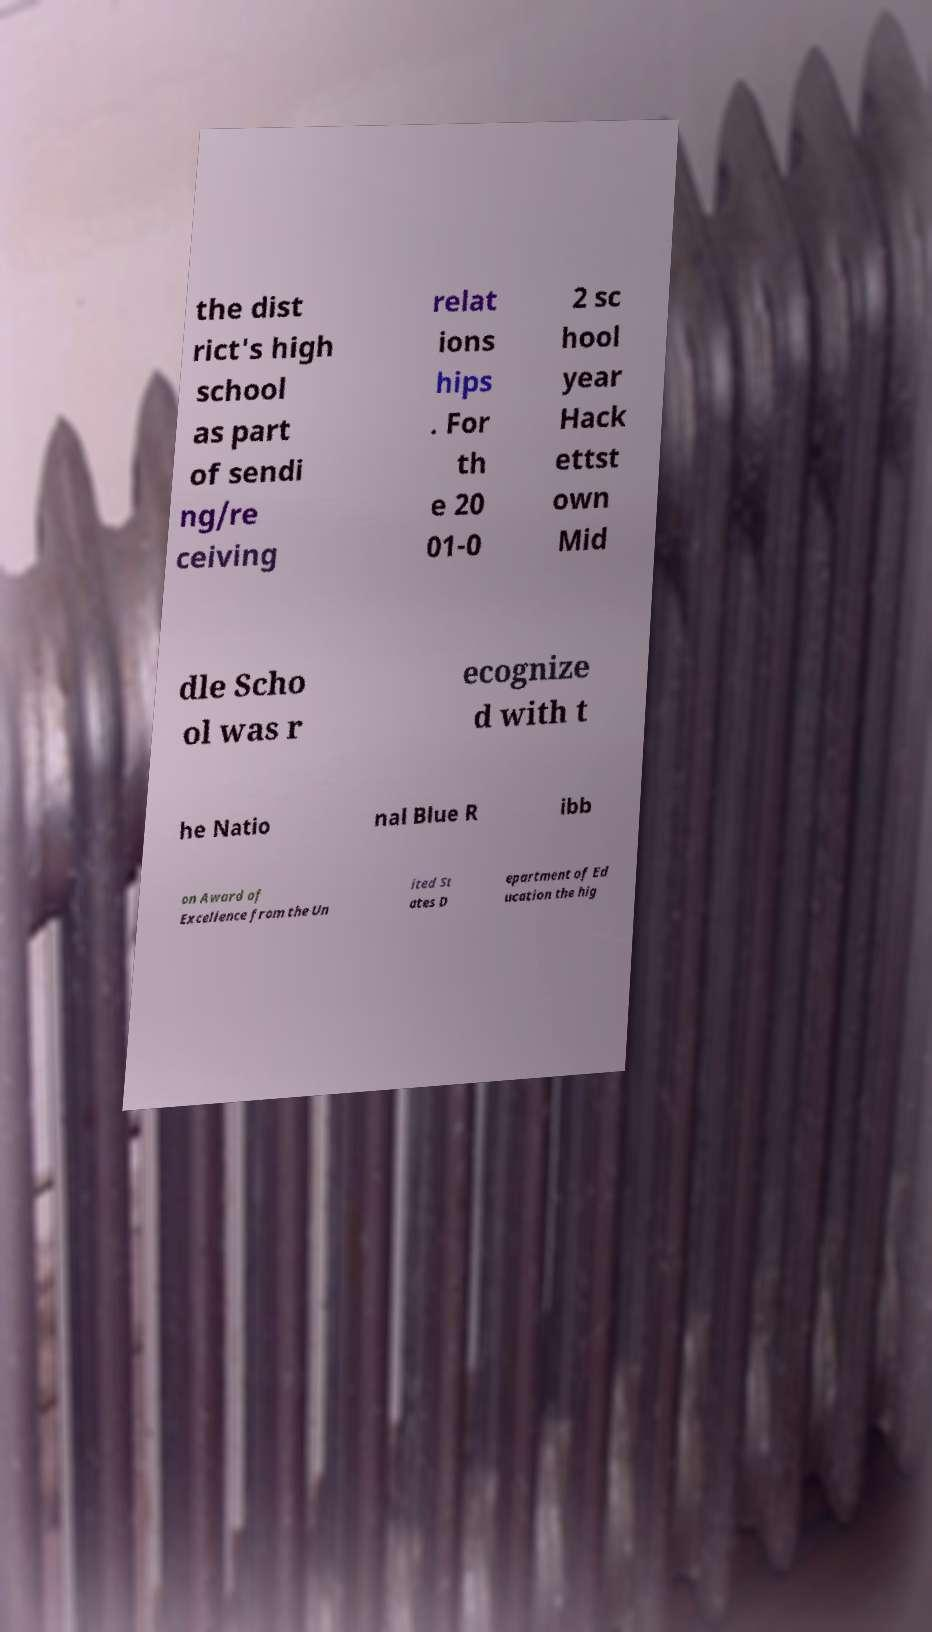Could you extract and type out the text from this image? the dist rict's high school as part of sendi ng/re ceiving relat ions hips . For th e 20 01-0 2 sc hool year Hack ettst own Mid dle Scho ol was r ecognize d with t he Natio nal Blue R ibb on Award of Excellence from the Un ited St ates D epartment of Ed ucation the hig 